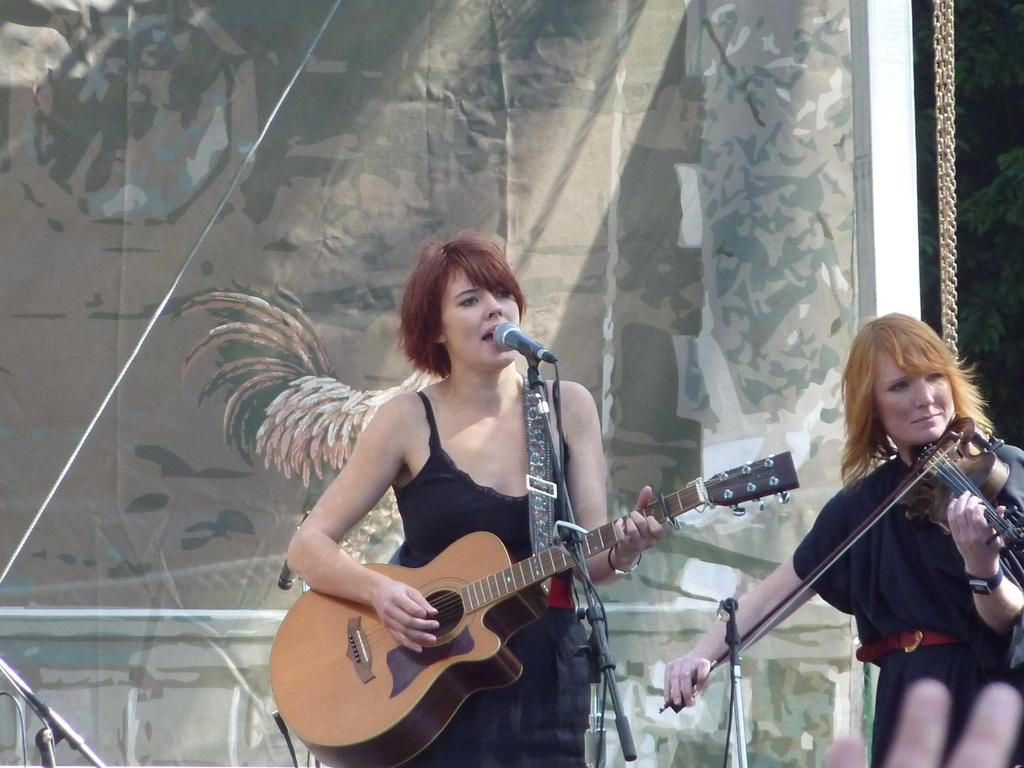How many people are in the image? There are two people in the image. What are the people doing in the image? Both people are standing and playing musical instruments. Where is the nearest downtown area to the location of the image? The provided facts do not give any information about the location of the image, so it is impossible to determine the nearest downtown area. 